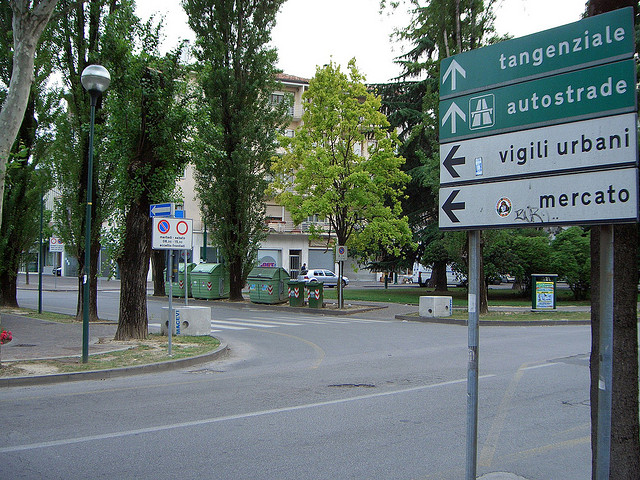<image>What language are these directional signs in? I am not sure what language the directional signs are in. They could be in Spanish, German, Italian, French, or even Russian. What language are these directional signs in? I don't know what language are these directional signs in. It can be seen Spanish, German, Italian, French, and Russian. 